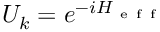Convert formula to latex. <formula><loc_0><loc_0><loc_500><loc_500>U _ { k } = e ^ { - i H _ { e f f } }</formula> 